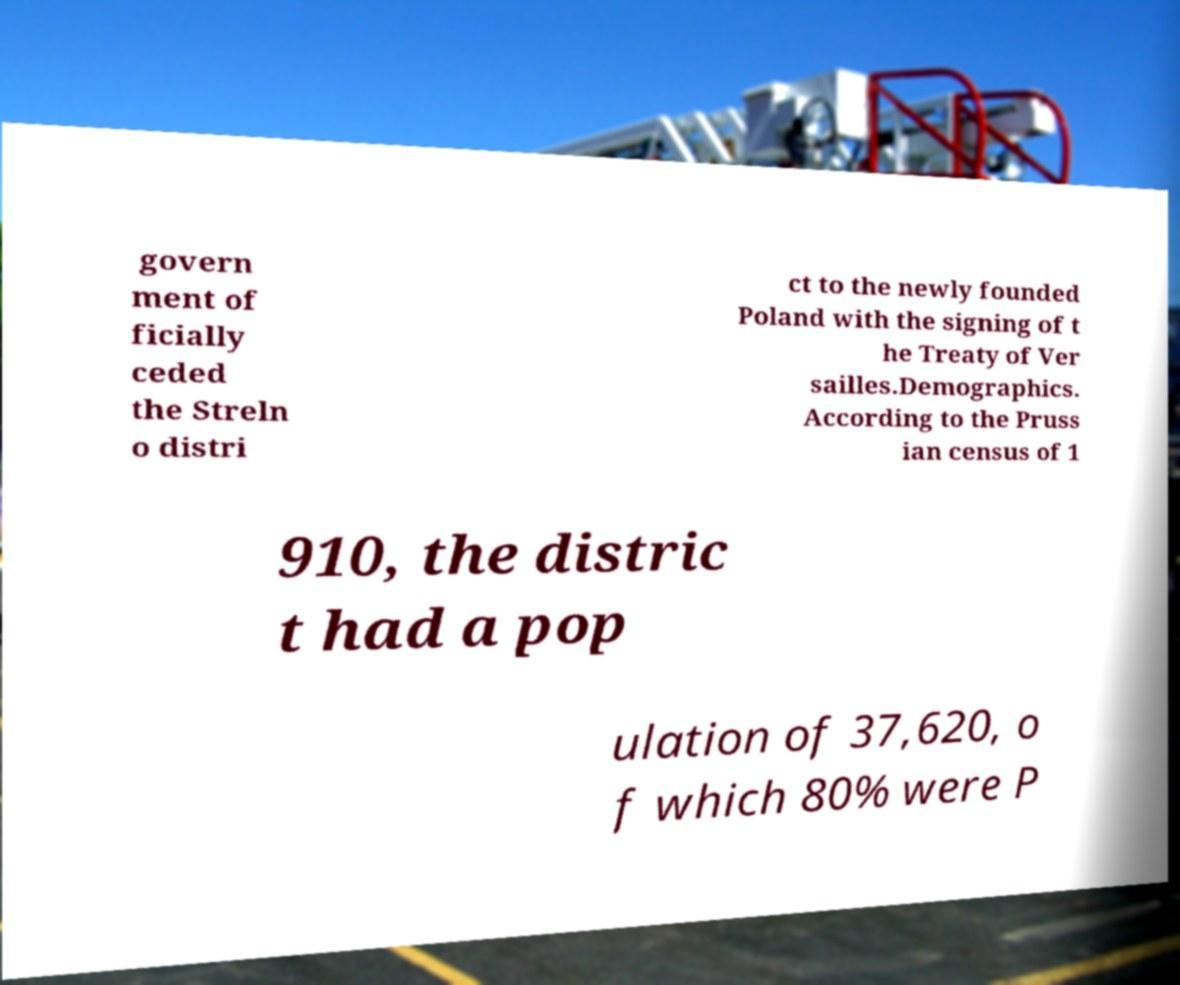Could you assist in decoding the text presented in this image and type it out clearly? govern ment of ficially ceded the Streln o distri ct to the newly founded Poland with the signing of t he Treaty of Ver sailles.Demographics. According to the Pruss ian census of 1 910, the distric t had a pop ulation of 37,620, o f which 80% were P 